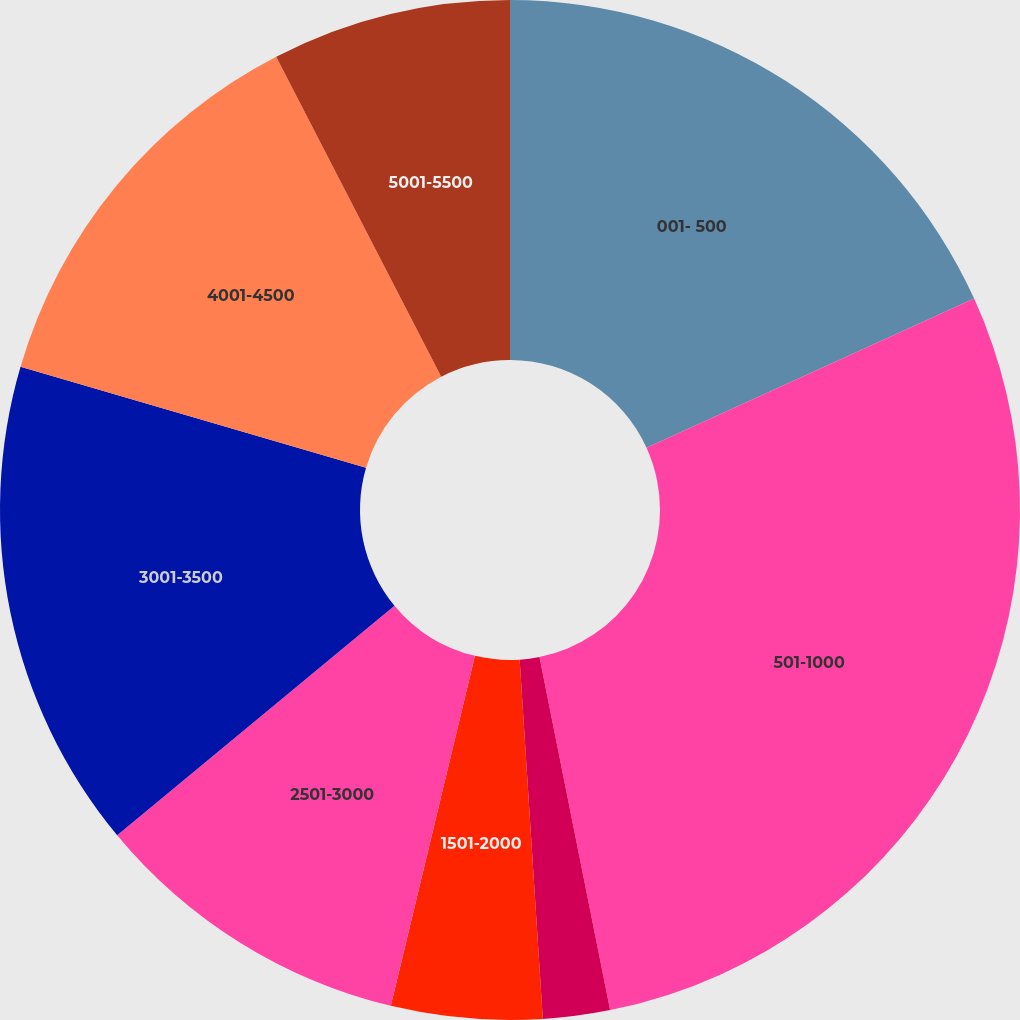Convert chart to OTSL. <chart><loc_0><loc_0><loc_500><loc_500><pie_chart><fcel>001- 500<fcel>501-1000<fcel>1001-1500<fcel>1501-2000<fcel>2501-3000<fcel>3001-3500<fcel>4001-4500<fcel>5001-5500<nl><fcel>18.2%<fcel>28.66%<fcel>2.12%<fcel>4.78%<fcel>10.24%<fcel>15.54%<fcel>12.89%<fcel>7.58%<nl></chart> 